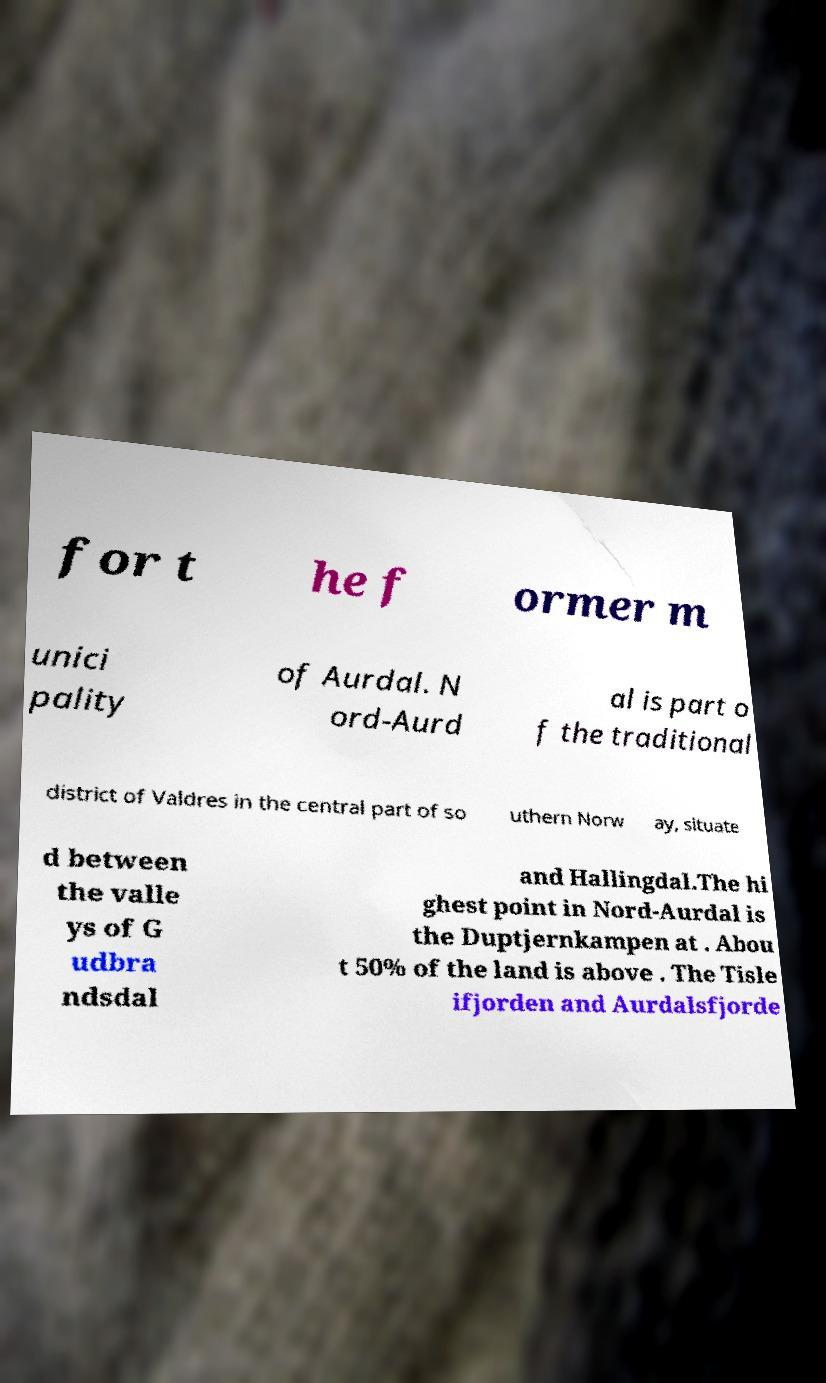Please identify and transcribe the text found in this image. for t he f ormer m unici pality of Aurdal. N ord-Aurd al is part o f the traditional district of Valdres in the central part of so uthern Norw ay, situate d between the valle ys of G udbra ndsdal and Hallingdal.The hi ghest point in Nord-Aurdal is the Duptjernkampen at . Abou t 50% of the land is above . The Tisle ifjorden and Aurdalsfjorde 